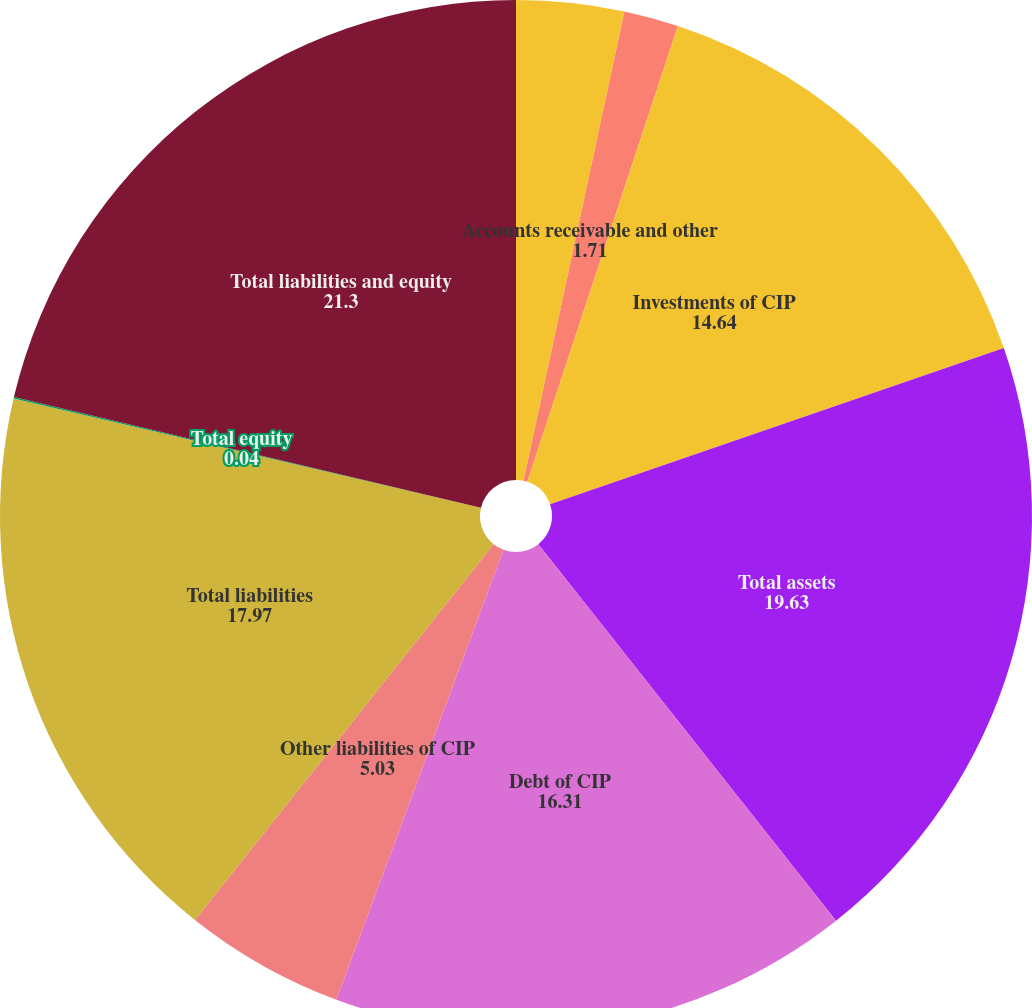Convert chart to OTSL. <chart><loc_0><loc_0><loc_500><loc_500><pie_chart><fcel>Cash and cash equivalents of<fcel>Accounts receivable and other<fcel>Investments of CIP<fcel>Total assets<fcel>Debt of CIP<fcel>Other liabilities of CIP<fcel>Total liabilities<fcel>Total equity<fcel>Total liabilities and equity<nl><fcel>3.37%<fcel>1.71%<fcel>14.64%<fcel>19.63%<fcel>16.31%<fcel>5.03%<fcel>17.97%<fcel>0.04%<fcel>21.3%<nl></chart> 